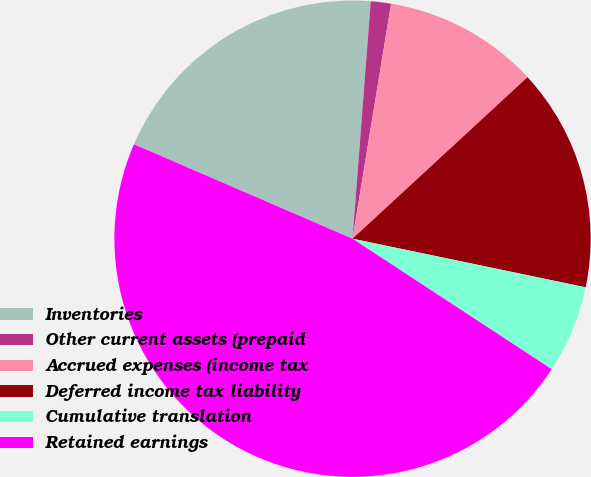Convert chart. <chart><loc_0><loc_0><loc_500><loc_500><pie_chart><fcel>Inventories<fcel>Other current assets (prepaid<fcel>Accrued expenses (income tax<fcel>Deferred income tax liability<fcel>Cumulative translation<fcel>Retained earnings<nl><fcel>19.73%<fcel>1.37%<fcel>10.55%<fcel>15.14%<fcel>5.96%<fcel>47.27%<nl></chart> 